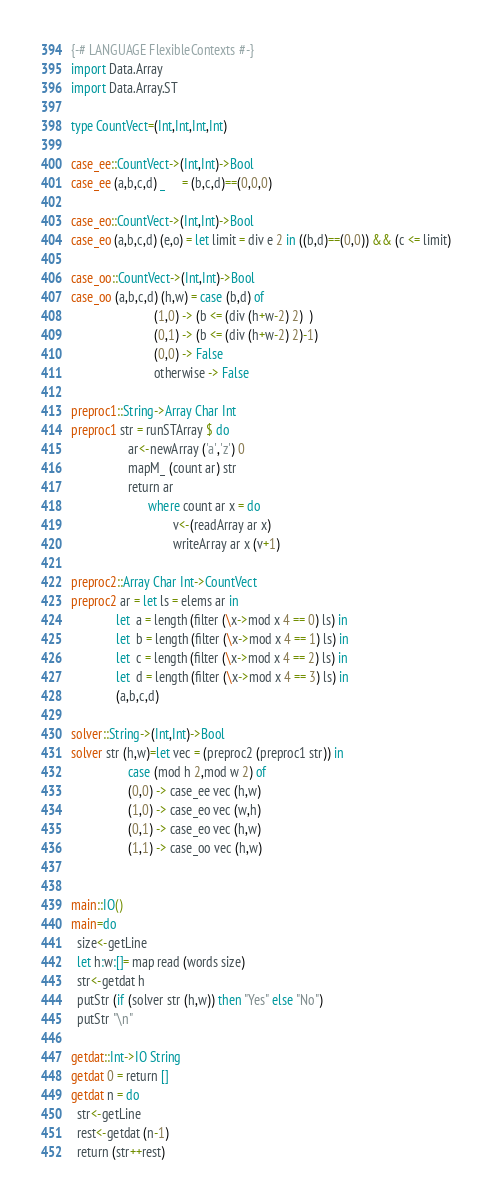<code> <loc_0><loc_0><loc_500><loc_500><_Haskell_>
{-# LANGUAGE FlexibleContexts #-}
import Data.Array
import Data.Array.ST

type CountVect=(Int,Int,Int,Int)

case_ee::CountVect->(Int,Int)->Bool
case_ee (a,b,c,d) _     = (b,c,d)==(0,0,0)

case_eo::CountVect->(Int,Int)->Bool
case_eo (a,b,c,d) (e,o) = let limit = div e 2 in ((b,d)==(0,0)) && (c <= limit)

case_oo::CountVect->(Int,Int)->Bool
case_oo (a,b,c,d) (h,w) = case (b,d) of
                          (1,0) -> (b <= (div (h+w-2) 2)  )
                          (0,1) -> (b <= (div (h+w-2) 2)-1)
                          (0,0) -> False
                          otherwise -> False

preproc1::String->Array Char Int
preproc1 str = runSTArray $ do
                  ar<-newArray ('a','z') 0
                  mapM_ (count ar) str
                  return ar
                        where count ar x = do
                                v<-(readArray ar x)
                                writeArray ar x (v+1)

preproc2::Array Char Int->CountVect
preproc2 ar = let ls = elems ar in
              let  a = length (filter (\x->mod x 4 == 0) ls) in
              let  b = length (filter (\x->mod x 4 == 1) ls) in
              let  c = length (filter (\x->mod x 4 == 2) ls) in
              let  d = length (filter (\x->mod x 4 == 3) ls) in
              (a,b,c,d)

solver::String->(Int,Int)->Bool
solver str (h,w)=let vec = (preproc2 (preproc1 str)) in
                  case (mod h 2,mod w 2) of
                  (0,0) -> case_ee vec (h,w)
                  (1,0) -> case_eo vec (w,h)
                  (0,1) -> case_eo vec (h,w)
                  (1,1) -> case_oo vec (h,w)


main::IO()
main=do
  size<-getLine
  let h:w:[]= map read (words size)
  str<-getdat h
  putStr (if (solver str (h,w)) then "Yes" else "No")
  putStr "\n"

getdat::Int->IO String
getdat 0 = return []
getdat n = do
  str<-getLine
  rest<-getdat (n-1)
  return (str++rest)</code> 